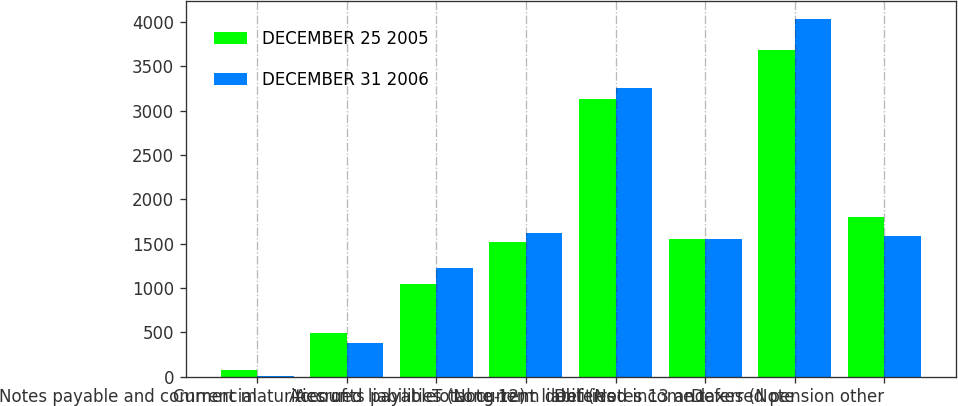<chart> <loc_0><loc_0><loc_500><loc_500><stacked_bar_chart><ecel><fcel>Notes payable and commercial<fcel>Current maturities of<fcel>Accounts payable<fcel>Accrued liabilities (Note 12)<fcel>Total current liabilities<fcel>Long-term debt (Notes 13 and<fcel>Deferred income taxes (Note<fcel>Deferred pension other<nl><fcel>DECEMBER 25 2005<fcel>72<fcel>494<fcel>1048<fcel>1515<fcel>3129<fcel>1553<fcel>3691<fcel>1796<nl><fcel>DECEMBER 31 2006<fcel>3<fcel>381<fcel>1227<fcel>1622<fcel>3255<fcel>1553<fcel>4032<fcel>1591<nl></chart> 